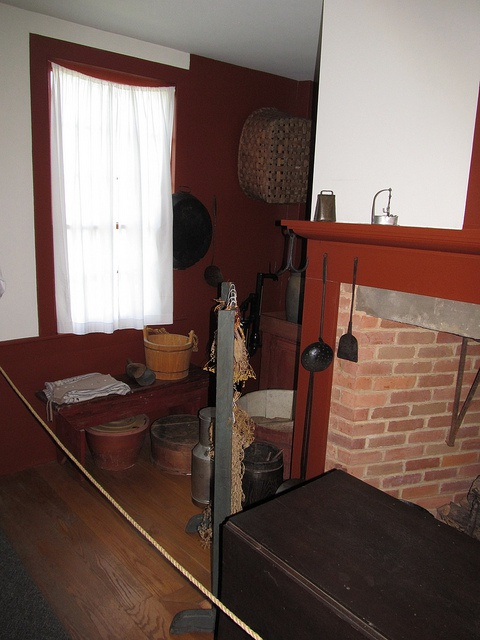Describe the objects in this image and their specific colors. I can see bench in gray, black, and maroon tones and spoon in gray, black, maroon, and darkgray tones in this image. 